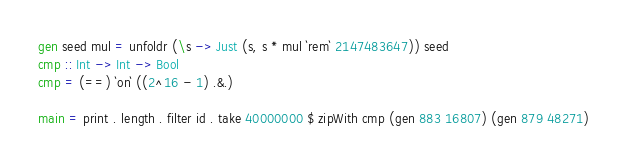Convert code to text. <code><loc_0><loc_0><loc_500><loc_500><_Haskell_>gen seed mul = unfoldr (\s -> Just (s, s * mul `rem` 2147483647)) seed
cmp :: Int -> Int -> Bool
cmp = (==) `on` ((2^16 - 1) .&.)

main = print . length . filter id . take 40000000 $ zipWith cmp (gen 883 16807) (gen 879 48271)
</code> 